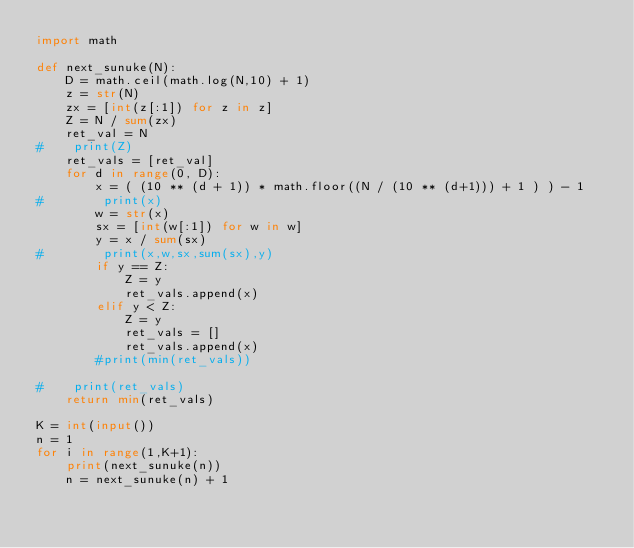Convert code to text. <code><loc_0><loc_0><loc_500><loc_500><_Python_>import math

def next_sunuke(N):
    D = math.ceil(math.log(N,10) + 1)
    z = str(N)
    zx = [int(z[:1]) for z in z]
    Z = N / sum(zx)
    ret_val = N
#    print(Z)
    ret_vals = [ret_val]
    for d in range(0, D):
        x = ( (10 ** (d + 1)) * math.floor((N / (10 ** (d+1))) + 1 ) ) - 1
#        print(x)
        w = str(x)
        sx = [int(w[:1]) for w in w]
        y = x / sum(sx)
#        print(x,w,sx,sum(sx),y)
        if y == Z:
            Z = y
            ret_vals.append(x)
        elif y < Z:
            Z = y
            ret_vals = []
            ret_vals.append(x)
        #print(min(ret_vals))

#    print(ret_vals)
    return min(ret_vals)

K = int(input())
n = 1
for i in range(1,K+1):
    print(next_sunuke(n))
    n = next_sunuke(n) + 1
</code> 